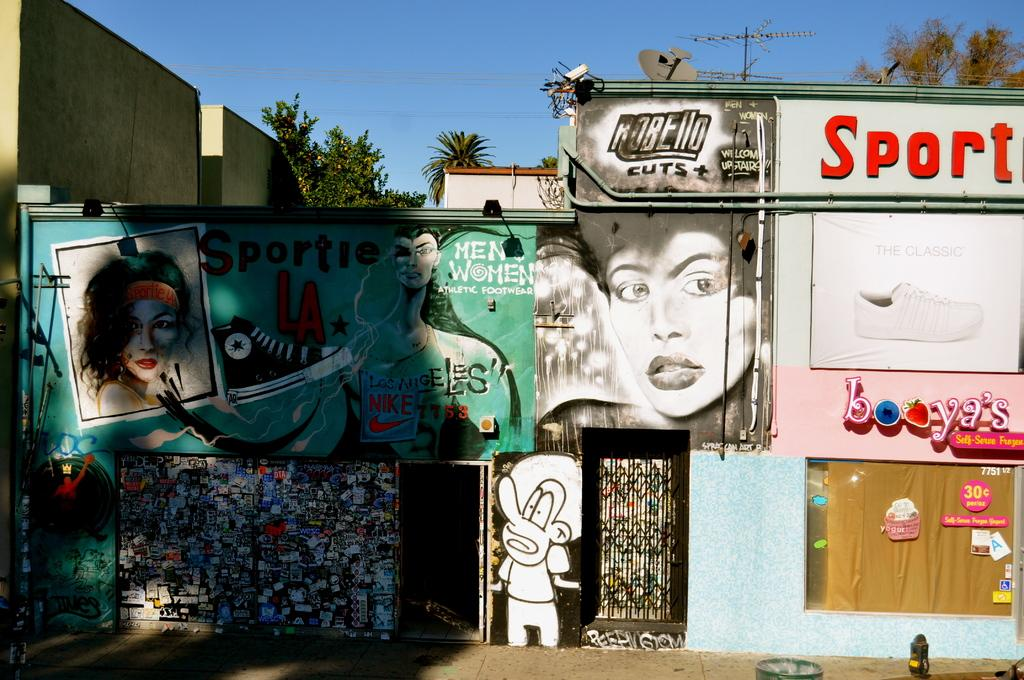Where was the image taken? The image was clicked outside. What can be seen on the walls in the image? There is graffiti in the image. What type of vegetation is visible at the top of the image? There are trees at the top of the image. What is visible in the background of the image? The sky is visible at the top of the image. Can you tell me how many brothers are present in the image? There is no reference to any brothers in the image, as it features graffiti, trees, and the sky. 